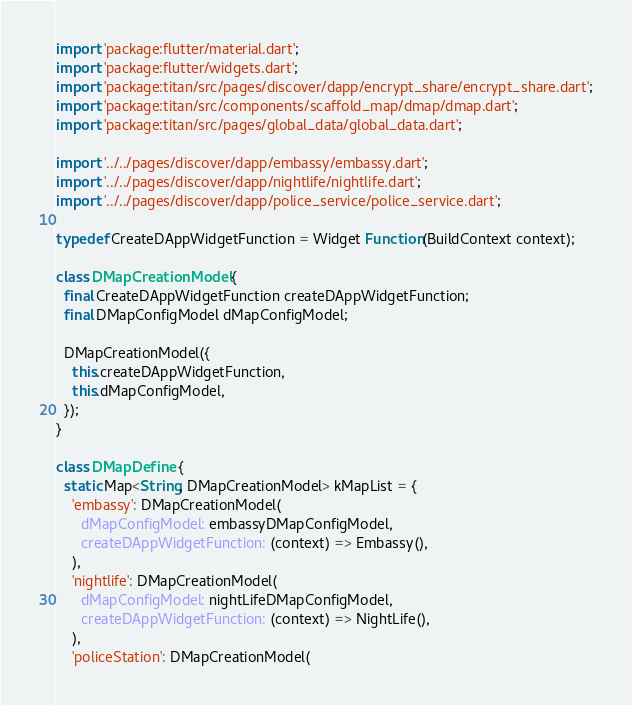Convert code to text. <code><loc_0><loc_0><loc_500><loc_500><_Dart_>import 'package:flutter/material.dart';
import 'package:flutter/widgets.dart';
import 'package:titan/src/pages/discover/dapp/encrypt_share/encrypt_share.dart';
import 'package:titan/src/components/scaffold_map/dmap/dmap.dart';
import 'package:titan/src/pages/global_data/global_data.dart';

import '../../pages/discover/dapp/embassy/embassy.dart';
import '../../pages/discover/dapp/nightlife/nightlife.dart';
import '../../pages/discover/dapp/police_service/police_service.dart';

typedef CreateDAppWidgetFunction = Widget Function(BuildContext context);

class DMapCreationModel {
  final CreateDAppWidgetFunction createDAppWidgetFunction;
  final DMapConfigModel dMapConfigModel;

  DMapCreationModel({
    this.createDAppWidgetFunction,
    this.dMapConfigModel,
  });
}

class DMapDefine {
  static Map<String, DMapCreationModel> kMapList = {
    'embassy': DMapCreationModel(
      dMapConfigModel: embassyDMapConfigModel,
      createDAppWidgetFunction: (context) => Embassy(),
    ),
    'nightlife': DMapCreationModel(
      dMapConfigModel: nightLifeDMapConfigModel,
      createDAppWidgetFunction: (context) => NightLife(),
    ),
    'policeStation': DMapCreationModel(</code> 